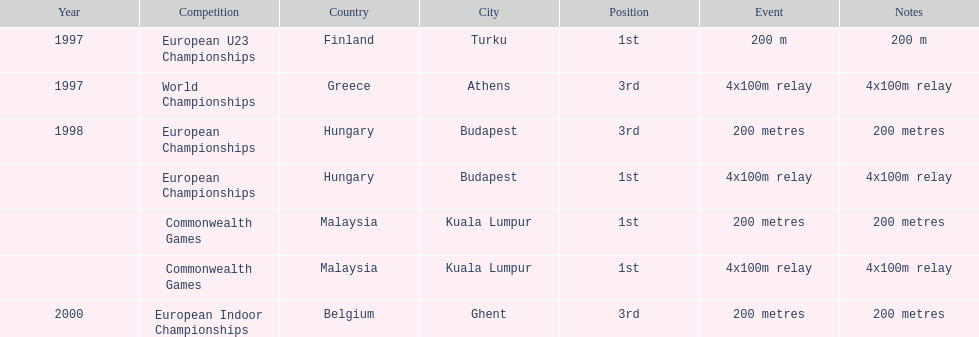How many times was golding in 2nd position? 0. 